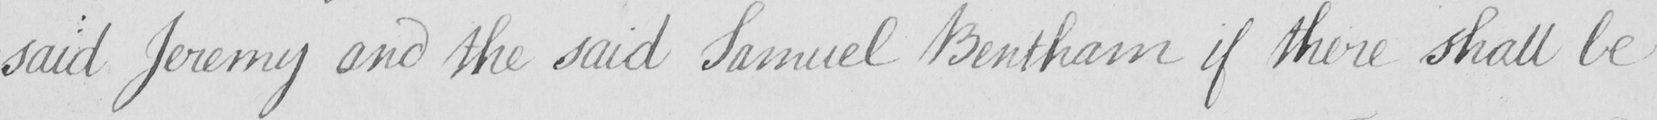Please provide the text content of this handwritten line. said Jeremy and the said Samuel Bentham if there shall be 